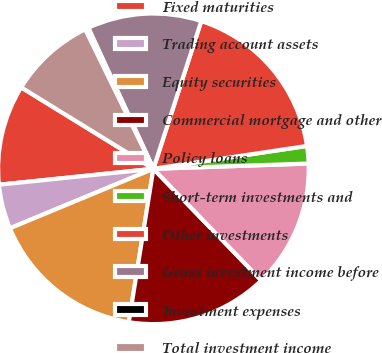<chart> <loc_0><loc_0><loc_500><loc_500><pie_chart><fcel>Fixed maturities<fcel>Trading account assets<fcel>Equity securities<fcel>Commercial mortgage and other<fcel>Policy loans<fcel>Short-term investments and<fcel>Other investments<fcel>Gross investment income before<fcel>Investment expenses<fcel>Total investment income<nl><fcel>10.42%<fcel>4.62%<fcel>16.21%<fcel>14.76%<fcel>13.31%<fcel>1.81%<fcel>17.66%<fcel>11.87%<fcel>0.36%<fcel>8.97%<nl></chart> 